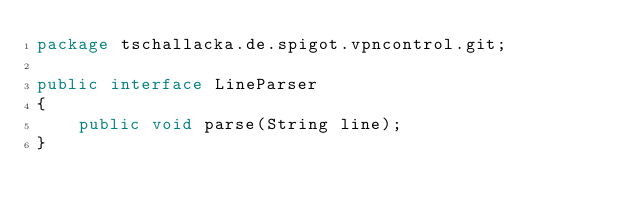<code> <loc_0><loc_0><loc_500><loc_500><_Java_>package tschallacka.de.spigot.vpncontrol.git;

public interface LineParser
{
    public void parse(String line);
}
</code> 